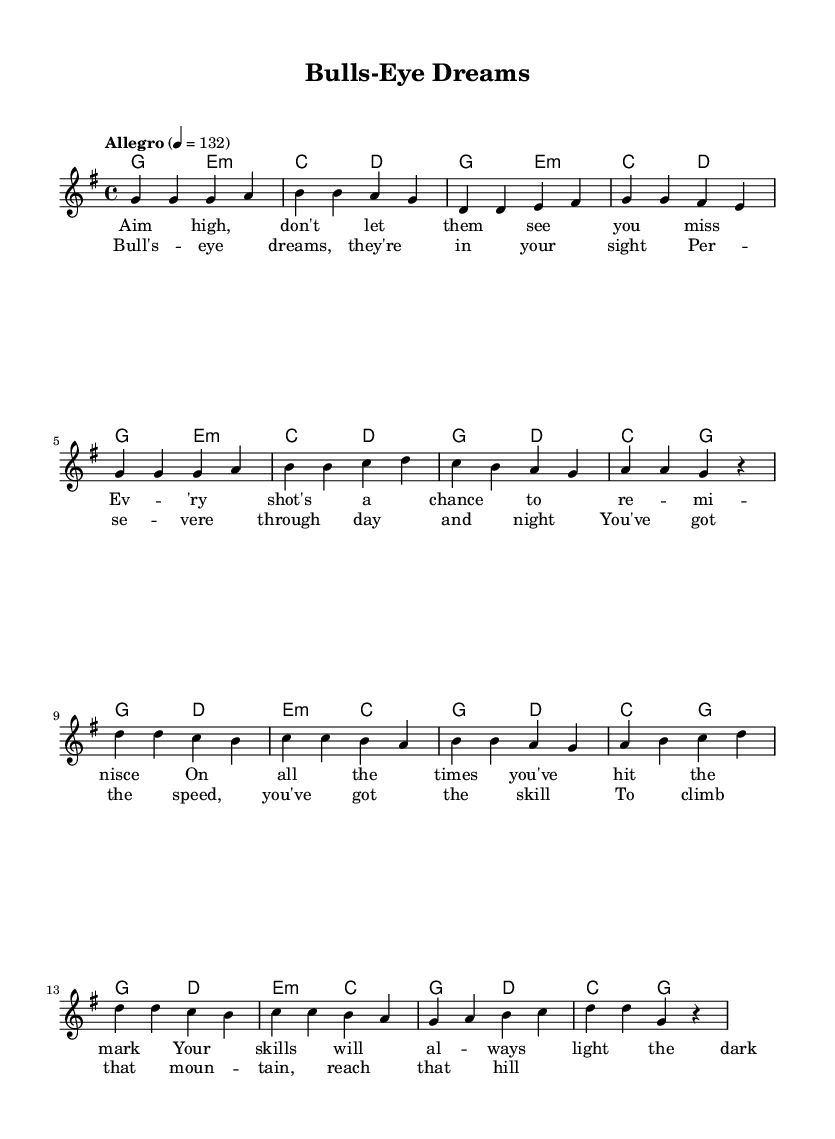What is the key signature of this music? The key signature is G major, which has one sharp (F#). This is indicated at the beginning of the sheet music after the clef sign.
Answer: G major What is the time signature of the piece? The time signature is 4/4, which means there are four beats in each measure and the quarter note gets one beat. This is found at the start of the piece.
Answer: 4/4 What is the tempo marking for this composition? The tempo marking is "Allegro" at a speed of 132 beats per minute. This is noted at the start of the music, indicating a fast, lively pace.
Answer: Allegro What is the primary lyrical theme of the chorus? The primary lyrical theme of the chorus revolves around dreams and perseverance, as highlighted in the phrase "Bull's-eye dreams, they're in your sight." This is evident from the words in the chorus lyrics.
Answer: Dreams What chords are used during the chorus section? The chords used in the chorus include G, D, E minor, and C, which are indicated in the harmonies part corresponding to the melodic sections of the chorus.
Answer: G, D, E minor, C How does the melody of the chorus differ from the verse? The melody of the chorus is more dynamic and has a higher range compared to the verse, showcasing an uplifting and anthem-like quality typical in pop songs. This can be identified by comparing the note pitches in both sections.
Answer: Higher and more dynamic 